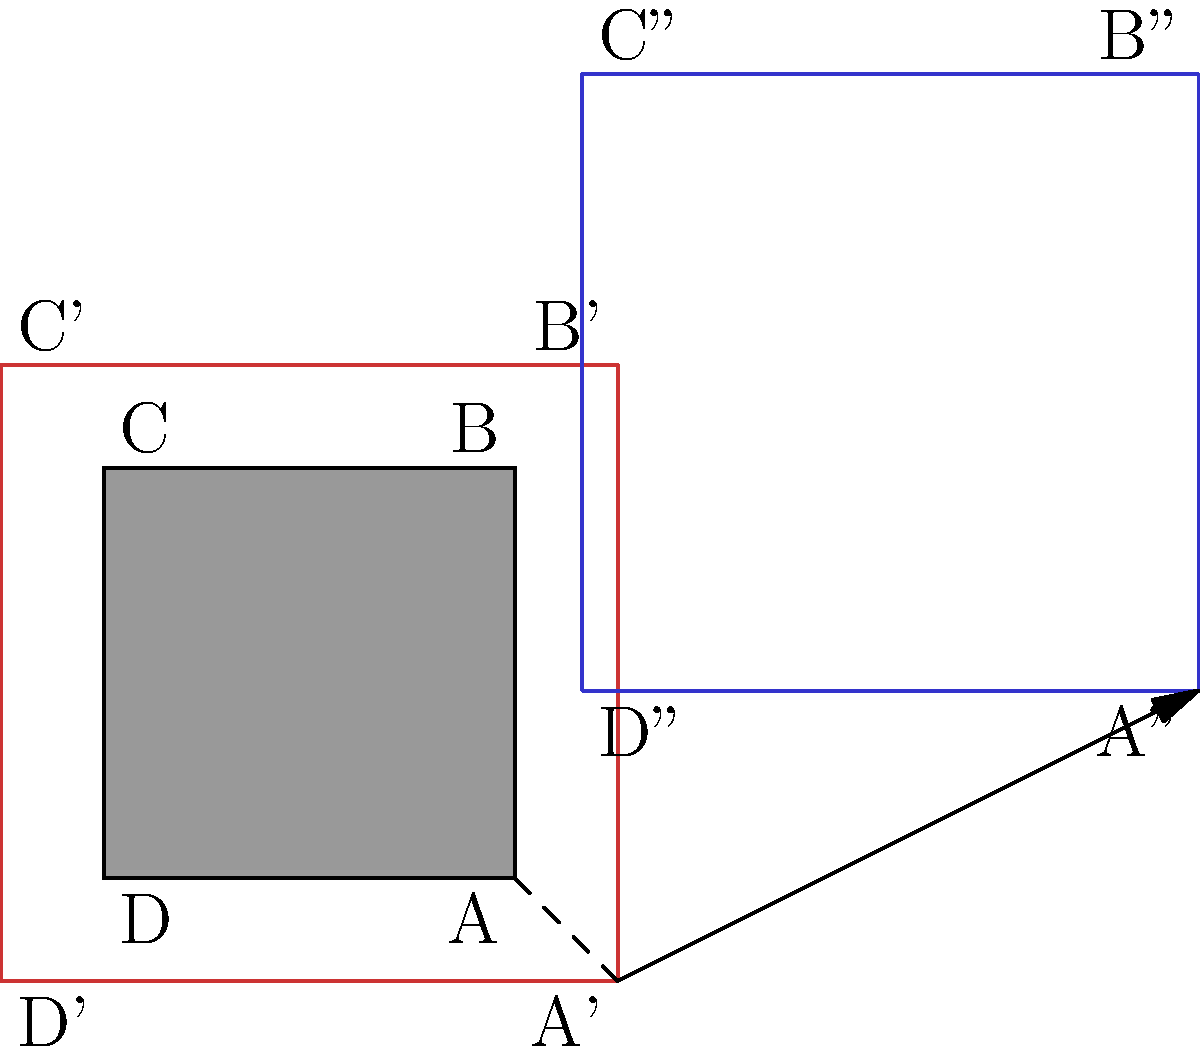Miles Kane is planning a special concert and wants to transform the shape of his usual square venue. The venue is first dilated by a scale factor of 1.5, and then translated 2 units right and 1 unit up. If the original venue had side length 10 meters, what is the area of the final transformed venue in square meters? Let's approach this step-by-step:

1) The original venue is a square with side length 10 meters.
   Area of original venue = $10^2 = 100$ sq meters

2) The venue is first dilated by a scale factor of 1.5.
   New side length after dilation = $10 * 1.5 = 15$ meters
   
3) The area scales by the square of the scale factor:
   New area after dilation = $100 * 1.5^2 = 100 * 2.25 = 225$ sq meters

4) The venue is then translated 2 units right and 1 unit up.
   Translation does not affect the area of the shape.

Therefore, the final area of the transformed venue is 225 square meters.
Answer: 225 sq meters 